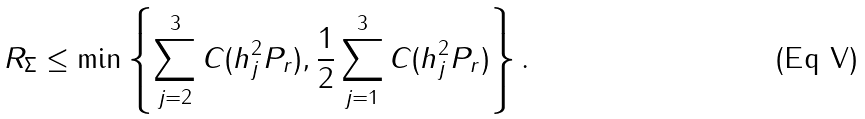Convert formula to latex. <formula><loc_0><loc_0><loc_500><loc_500>R _ { \Sigma } \leq \min \left \{ \sum _ { j = 2 } ^ { 3 } C ( h _ { j } ^ { 2 } P _ { r } ) , \frac { 1 } { 2 } \sum _ { j = 1 } ^ { 3 } C ( h _ { j } ^ { 2 } P _ { r } ) \right \} .</formula> 